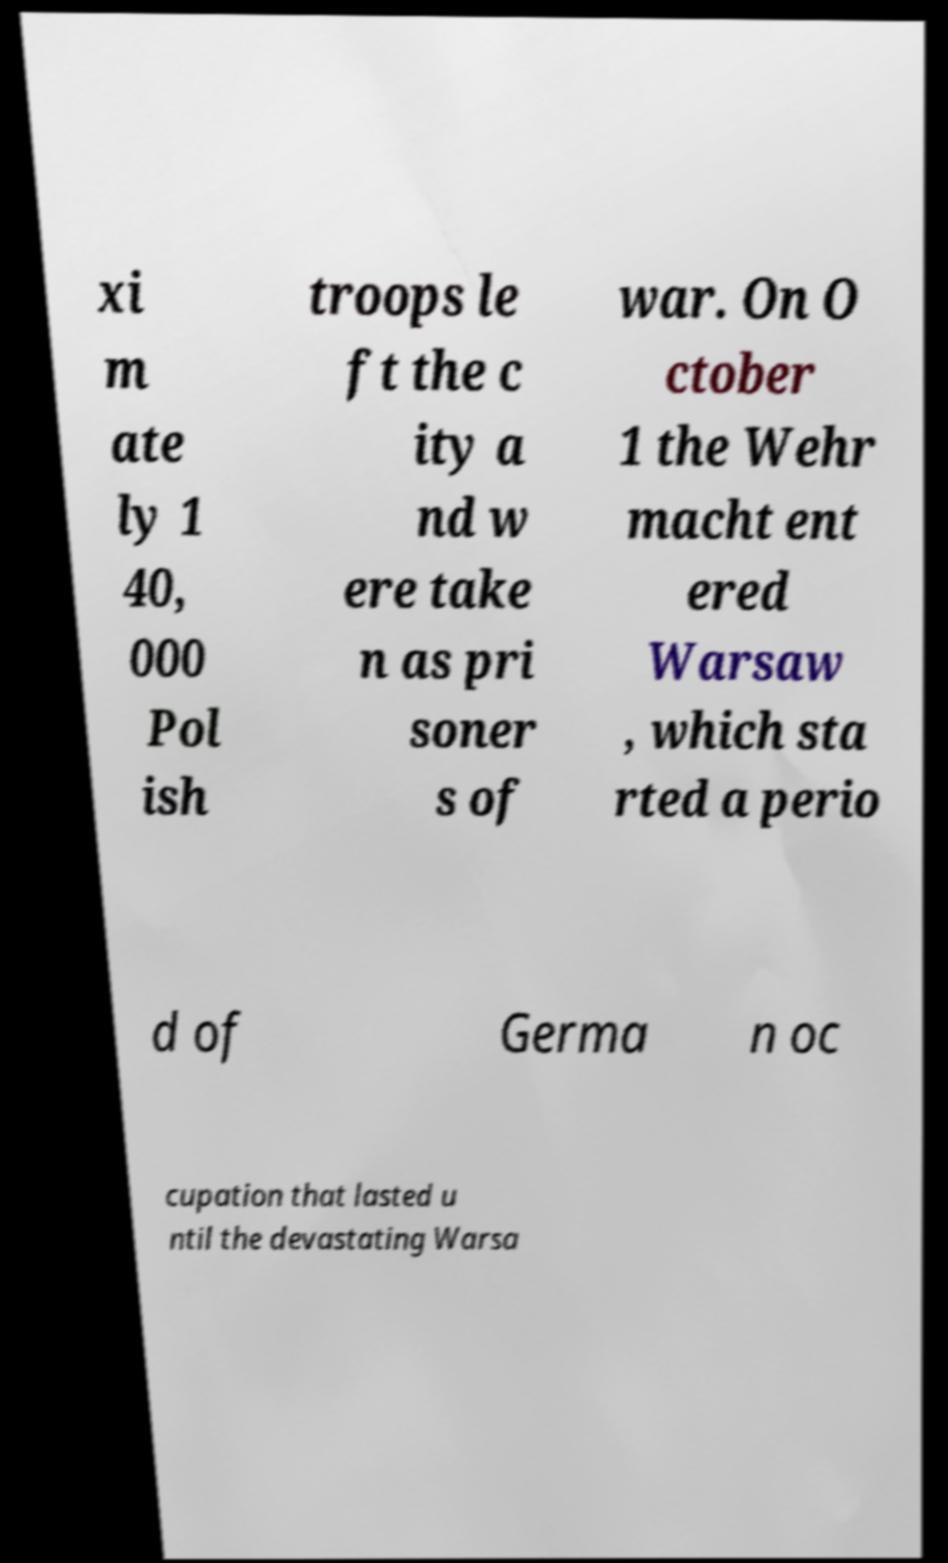Please read and relay the text visible in this image. What does it say? xi m ate ly 1 40, 000 Pol ish troops le ft the c ity a nd w ere take n as pri soner s of war. On O ctober 1 the Wehr macht ent ered Warsaw , which sta rted a perio d of Germa n oc cupation that lasted u ntil the devastating Warsa 